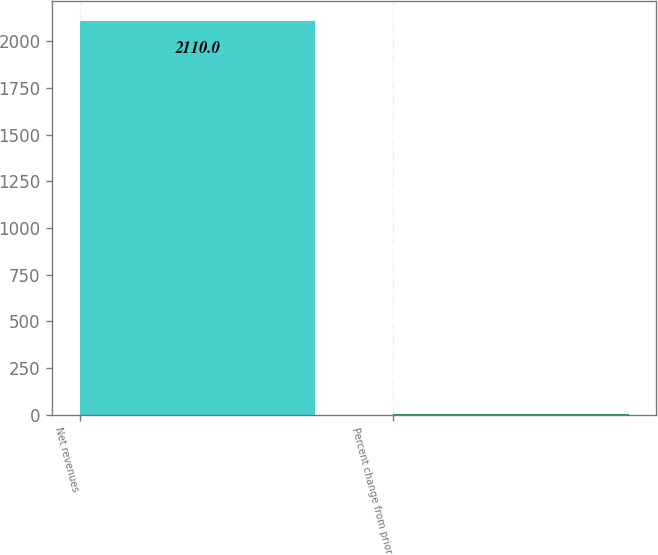Convert chart. <chart><loc_0><loc_0><loc_500><loc_500><bar_chart><fcel>Net revenues<fcel>Percent change from prior<nl><fcel>2110<fcel>2<nl></chart> 